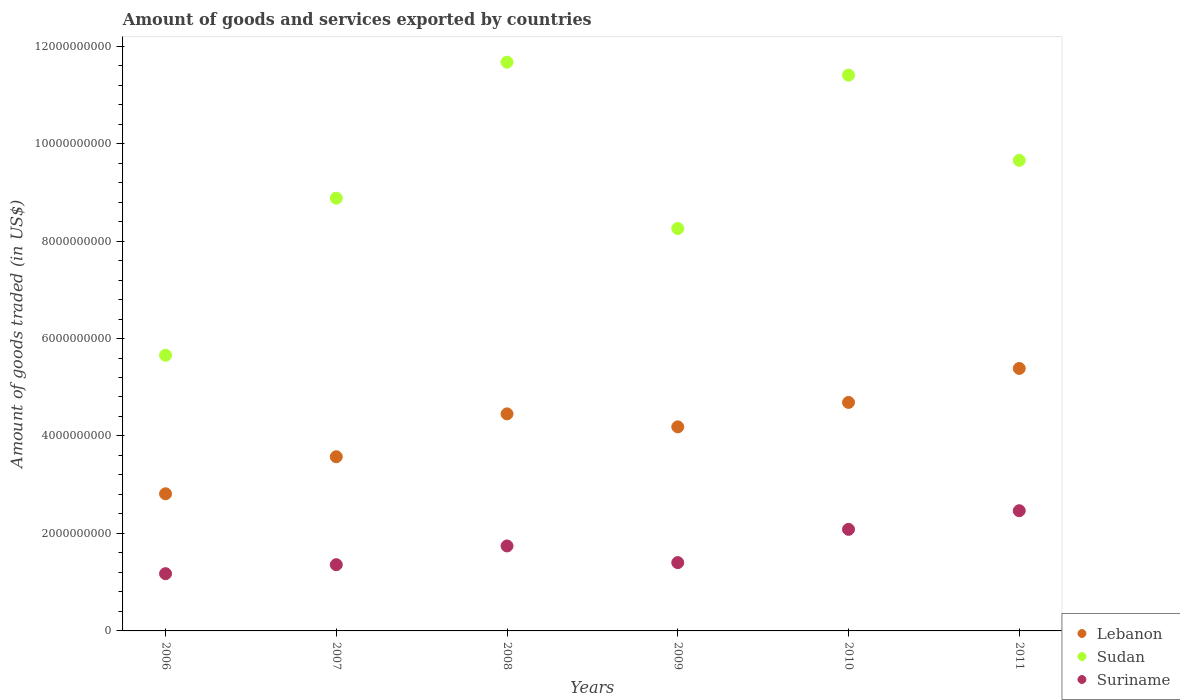Is the number of dotlines equal to the number of legend labels?
Ensure brevity in your answer.  Yes. What is the total amount of goods and services exported in Sudan in 2011?
Ensure brevity in your answer.  9.66e+09. Across all years, what is the maximum total amount of goods and services exported in Lebanon?
Offer a terse response. 5.39e+09. Across all years, what is the minimum total amount of goods and services exported in Sudan?
Your response must be concise. 5.66e+09. What is the total total amount of goods and services exported in Suriname in the graph?
Make the answer very short. 1.02e+1. What is the difference between the total amount of goods and services exported in Suriname in 2008 and that in 2011?
Keep it short and to the point. -7.23e+08. What is the difference between the total amount of goods and services exported in Suriname in 2011 and the total amount of goods and services exported in Sudan in 2010?
Ensure brevity in your answer.  -8.94e+09. What is the average total amount of goods and services exported in Suriname per year?
Provide a succinct answer. 1.70e+09. In the year 2009, what is the difference between the total amount of goods and services exported in Suriname and total amount of goods and services exported in Sudan?
Make the answer very short. -6.86e+09. What is the ratio of the total amount of goods and services exported in Suriname in 2007 to that in 2010?
Keep it short and to the point. 0.65. Is the difference between the total amount of goods and services exported in Suriname in 2007 and 2011 greater than the difference between the total amount of goods and services exported in Sudan in 2007 and 2011?
Your answer should be very brief. No. What is the difference between the highest and the second highest total amount of goods and services exported in Sudan?
Give a very brief answer. 2.66e+08. What is the difference between the highest and the lowest total amount of goods and services exported in Suriname?
Offer a very short reply. 1.29e+09. In how many years, is the total amount of goods and services exported in Suriname greater than the average total amount of goods and services exported in Suriname taken over all years?
Your response must be concise. 3. Is the total amount of goods and services exported in Lebanon strictly less than the total amount of goods and services exported in Sudan over the years?
Give a very brief answer. Yes. How are the legend labels stacked?
Offer a very short reply. Vertical. What is the title of the graph?
Keep it short and to the point. Amount of goods and services exported by countries. What is the label or title of the X-axis?
Provide a succinct answer. Years. What is the label or title of the Y-axis?
Keep it short and to the point. Amount of goods traded (in US$). What is the Amount of goods traded (in US$) in Lebanon in 2006?
Offer a terse response. 2.81e+09. What is the Amount of goods traded (in US$) in Sudan in 2006?
Make the answer very short. 5.66e+09. What is the Amount of goods traded (in US$) in Suriname in 2006?
Give a very brief answer. 1.17e+09. What is the Amount of goods traded (in US$) in Lebanon in 2007?
Keep it short and to the point. 3.57e+09. What is the Amount of goods traded (in US$) in Sudan in 2007?
Ensure brevity in your answer.  8.88e+09. What is the Amount of goods traded (in US$) of Suriname in 2007?
Make the answer very short. 1.36e+09. What is the Amount of goods traded (in US$) in Lebanon in 2008?
Keep it short and to the point. 4.45e+09. What is the Amount of goods traded (in US$) of Sudan in 2008?
Provide a succinct answer. 1.17e+1. What is the Amount of goods traded (in US$) of Suriname in 2008?
Provide a succinct answer. 1.74e+09. What is the Amount of goods traded (in US$) of Lebanon in 2009?
Your answer should be compact. 4.19e+09. What is the Amount of goods traded (in US$) in Sudan in 2009?
Your response must be concise. 8.26e+09. What is the Amount of goods traded (in US$) of Suriname in 2009?
Provide a short and direct response. 1.40e+09. What is the Amount of goods traded (in US$) of Lebanon in 2010?
Offer a terse response. 4.69e+09. What is the Amount of goods traded (in US$) in Sudan in 2010?
Your answer should be compact. 1.14e+1. What is the Amount of goods traded (in US$) of Suriname in 2010?
Make the answer very short. 2.08e+09. What is the Amount of goods traded (in US$) in Lebanon in 2011?
Keep it short and to the point. 5.39e+09. What is the Amount of goods traded (in US$) of Sudan in 2011?
Make the answer very short. 9.66e+09. What is the Amount of goods traded (in US$) of Suriname in 2011?
Offer a terse response. 2.47e+09. Across all years, what is the maximum Amount of goods traded (in US$) of Lebanon?
Make the answer very short. 5.39e+09. Across all years, what is the maximum Amount of goods traded (in US$) of Sudan?
Offer a very short reply. 1.17e+1. Across all years, what is the maximum Amount of goods traded (in US$) in Suriname?
Offer a terse response. 2.47e+09. Across all years, what is the minimum Amount of goods traded (in US$) of Lebanon?
Ensure brevity in your answer.  2.81e+09. Across all years, what is the minimum Amount of goods traded (in US$) of Sudan?
Provide a short and direct response. 5.66e+09. Across all years, what is the minimum Amount of goods traded (in US$) of Suriname?
Your answer should be very brief. 1.17e+09. What is the total Amount of goods traded (in US$) in Lebanon in the graph?
Your response must be concise. 2.51e+1. What is the total Amount of goods traded (in US$) in Sudan in the graph?
Provide a short and direct response. 5.55e+1. What is the total Amount of goods traded (in US$) in Suriname in the graph?
Your answer should be very brief. 1.02e+1. What is the difference between the Amount of goods traded (in US$) in Lebanon in 2006 and that in 2007?
Make the answer very short. -7.60e+08. What is the difference between the Amount of goods traded (in US$) in Sudan in 2006 and that in 2007?
Provide a short and direct response. -3.22e+09. What is the difference between the Amount of goods traded (in US$) of Suriname in 2006 and that in 2007?
Your answer should be very brief. -1.84e+08. What is the difference between the Amount of goods traded (in US$) of Lebanon in 2006 and that in 2008?
Provide a succinct answer. -1.64e+09. What is the difference between the Amount of goods traded (in US$) in Sudan in 2006 and that in 2008?
Offer a terse response. -6.01e+09. What is the difference between the Amount of goods traded (in US$) of Suriname in 2006 and that in 2008?
Give a very brief answer. -5.69e+08. What is the difference between the Amount of goods traded (in US$) in Lebanon in 2006 and that in 2009?
Provide a succinct answer. -1.37e+09. What is the difference between the Amount of goods traded (in US$) of Sudan in 2006 and that in 2009?
Ensure brevity in your answer.  -2.60e+09. What is the difference between the Amount of goods traded (in US$) in Suriname in 2006 and that in 2009?
Your answer should be compact. -2.27e+08. What is the difference between the Amount of goods traded (in US$) of Lebanon in 2006 and that in 2010?
Make the answer very short. -1.87e+09. What is the difference between the Amount of goods traded (in US$) of Sudan in 2006 and that in 2010?
Keep it short and to the point. -5.75e+09. What is the difference between the Amount of goods traded (in US$) of Suriname in 2006 and that in 2010?
Provide a short and direct response. -9.10e+08. What is the difference between the Amount of goods traded (in US$) in Lebanon in 2006 and that in 2011?
Ensure brevity in your answer.  -2.57e+09. What is the difference between the Amount of goods traded (in US$) of Sudan in 2006 and that in 2011?
Your response must be concise. -4.00e+09. What is the difference between the Amount of goods traded (in US$) in Suriname in 2006 and that in 2011?
Keep it short and to the point. -1.29e+09. What is the difference between the Amount of goods traded (in US$) of Lebanon in 2007 and that in 2008?
Your response must be concise. -8.79e+08. What is the difference between the Amount of goods traded (in US$) of Sudan in 2007 and that in 2008?
Ensure brevity in your answer.  -2.79e+09. What is the difference between the Amount of goods traded (in US$) in Suriname in 2007 and that in 2008?
Keep it short and to the point. -3.84e+08. What is the difference between the Amount of goods traded (in US$) of Lebanon in 2007 and that in 2009?
Ensure brevity in your answer.  -6.13e+08. What is the difference between the Amount of goods traded (in US$) of Sudan in 2007 and that in 2009?
Ensure brevity in your answer.  6.22e+08. What is the difference between the Amount of goods traded (in US$) in Suriname in 2007 and that in 2009?
Offer a very short reply. -4.28e+07. What is the difference between the Amount of goods traded (in US$) of Lebanon in 2007 and that in 2010?
Offer a terse response. -1.11e+09. What is the difference between the Amount of goods traded (in US$) in Sudan in 2007 and that in 2010?
Offer a terse response. -2.53e+09. What is the difference between the Amount of goods traded (in US$) of Suriname in 2007 and that in 2010?
Your answer should be very brief. -7.25e+08. What is the difference between the Amount of goods traded (in US$) in Lebanon in 2007 and that in 2011?
Offer a very short reply. -1.81e+09. What is the difference between the Amount of goods traded (in US$) in Sudan in 2007 and that in 2011?
Make the answer very short. -7.76e+08. What is the difference between the Amount of goods traded (in US$) in Suriname in 2007 and that in 2011?
Offer a terse response. -1.11e+09. What is the difference between the Amount of goods traded (in US$) in Lebanon in 2008 and that in 2009?
Provide a succinct answer. 2.67e+08. What is the difference between the Amount of goods traded (in US$) in Sudan in 2008 and that in 2009?
Your answer should be very brief. 3.41e+09. What is the difference between the Amount of goods traded (in US$) of Suriname in 2008 and that in 2009?
Offer a very short reply. 3.42e+08. What is the difference between the Amount of goods traded (in US$) of Lebanon in 2008 and that in 2010?
Make the answer very short. -2.35e+08. What is the difference between the Amount of goods traded (in US$) of Sudan in 2008 and that in 2010?
Make the answer very short. 2.66e+08. What is the difference between the Amount of goods traded (in US$) of Suriname in 2008 and that in 2010?
Give a very brief answer. -3.41e+08. What is the difference between the Amount of goods traded (in US$) in Lebanon in 2008 and that in 2011?
Offer a very short reply. -9.32e+08. What is the difference between the Amount of goods traded (in US$) of Sudan in 2008 and that in 2011?
Provide a succinct answer. 2.01e+09. What is the difference between the Amount of goods traded (in US$) in Suriname in 2008 and that in 2011?
Keep it short and to the point. -7.23e+08. What is the difference between the Amount of goods traded (in US$) of Lebanon in 2009 and that in 2010?
Ensure brevity in your answer.  -5.02e+08. What is the difference between the Amount of goods traded (in US$) of Sudan in 2009 and that in 2010?
Offer a very short reply. -3.15e+09. What is the difference between the Amount of goods traded (in US$) in Suriname in 2009 and that in 2010?
Offer a terse response. -6.82e+08. What is the difference between the Amount of goods traded (in US$) of Lebanon in 2009 and that in 2011?
Offer a very short reply. -1.20e+09. What is the difference between the Amount of goods traded (in US$) in Sudan in 2009 and that in 2011?
Give a very brief answer. -1.40e+09. What is the difference between the Amount of goods traded (in US$) in Suriname in 2009 and that in 2011?
Your response must be concise. -1.06e+09. What is the difference between the Amount of goods traded (in US$) in Lebanon in 2010 and that in 2011?
Offer a very short reply. -6.97e+08. What is the difference between the Amount of goods traded (in US$) in Sudan in 2010 and that in 2011?
Your answer should be compact. 1.75e+09. What is the difference between the Amount of goods traded (in US$) in Suriname in 2010 and that in 2011?
Keep it short and to the point. -3.83e+08. What is the difference between the Amount of goods traded (in US$) in Lebanon in 2006 and the Amount of goods traded (in US$) in Sudan in 2007?
Give a very brief answer. -6.07e+09. What is the difference between the Amount of goods traded (in US$) of Lebanon in 2006 and the Amount of goods traded (in US$) of Suriname in 2007?
Make the answer very short. 1.45e+09. What is the difference between the Amount of goods traded (in US$) of Sudan in 2006 and the Amount of goods traded (in US$) of Suriname in 2007?
Ensure brevity in your answer.  4.30e+09. What is the difference between the Amount of goods traded (in US$) of Lebanon in 2006 and the Amount of goods traded (in US$) of Sudan in 2008?
Your answer should be compact. -8.86e+09. What is the difference between the Amount of goods traded (in US$) in Lebanon in 2006 and the Amount of goods traded (in US$) in Suriname in 2008?
Keep it short and to the point. 1.07e+09. What is the difference between the Amount of goods traded (in US$) of Sudan in 2006 and the Amount of goods traded (in US$) of Suriname in 2008?
Your answer should be very brief. 3.91e+09. What is the difference between the Amount of goods traded (in US$) in Lebanon in 2006 and the Amount of goods traded (in US$) in Sudan in 2009?
Keep it short and to the point. -5.44e+09. What is the difference between the Amount of goods traded (in US$) in Lebanon in 2006 and the Amount of goods traded (in US$) in Suriname in 2009?
Give a very brief answer. 1.41e+09. What is the difference between the Amount of goods traded (in US$) in Sudan in 2006 and the Amount of goods traded (in US$) in Suriname in 2009?
Ensure brevity in your answer.  4.25e+09. What is the difference between the Amount of goods traded (in US$) in Lebanon in 2006 and the Amount of goods traded (in US$) in Sudan in 2010?
Your answer should be very brief. -8.59e+09. What is the difference between the Amount of goods traded (in US$) of Lebanon in 2006 and the Amount of goods traded (in US$) of Suriname in 2010?
Keep it short and to the point. 7.30e+08. What is the difference between the Amount of goods traded (in US$) in Sudan in 2006 and the Amount of goods traded (in US$) in Suriname in 2010?
Make the answer very short. 3.57e+09. What is the difference between the Amount of goods traded (in US$) of Lebanon in 2006 and the Amount of goods traded (in US$) of Sudan in 2011?
Your answer should be very brief. -6.84e+09. What is the difference between the Amount of goods traded (in US$) in Lebanon in 2006 and the Amount of goods traded (in US$) in Suriname in 2011?
Provide a short and direct response. 3.47e+08. What is the difference between the Amount of goods traded (in US$) in Sudan in 2006 and the Amount of goods traded (in US$) in Suriname in 2011?
Your answer should be very brief. 3.19e+09. What is the difference between the Amount of goods traded (in US$) of Lebanon in 2007 and the Amount of goods traded (in US$) of Sudan in 2008?
Make the answer very short. -8.10e+09. What is the difference between the Amount of goods traded (in US$) in Lebanon in 2007 and the Amount of goods traded (in US$) in Suriname in 2008?
Your answer should be compact. 1.83e+09. What is the difference between the Amount of goods traded (in US$) of Sudan in 2007 and the Amount of goods traded (in US$) of Suriname in 2008?
Your answer should be compact. 7.14e+09. What is the difference between the Amount of goods traded (in US$) in Lebanon in 2007 and the Amount of goods traded (in US$) in Sudan in 2009?
Your answer should be compact. -4.68e+09. What is the difference between the Amount of goods traded (in US$) of Lebanon in 2007 and the Amount of goods traded (in US$) of Suriname in 2009?
Offer a terse response. 2.17e+09. What is the difference between the Amount of goods traded (in US$) of Sudan in 2007 and the Amount of goods traded (in US$) of Suriname in 2009?
Provide a short and direct response. 7.48e+09. What is the difference between the Amount of goods traded (in US$) in Lebanon in 2007 and the Amount of goods traded (in US$) in Sudan in 2010?
Offer a very short reply. -7.83e+09. What is the difference between the Amount of goods traded (in US$) in Lebanon in 2007 and the Amount of goods traded (in US$) in Suriname in 2010?
Your response must be concise. 1.49e+09. What is the difference between the Amount of goods traded (in US$) in Sudan in 2007 and the Amount of goods traded (in US$) in Suriname in 2010?
Give a very brief answer. 6.80e+09. What is the difference between the Amount of goods traded (in US$) of Lebanon in 2007 and the Amount of goods traded (in US$) of Sudan in 2011?
Give a very brief answer. -6.08e+09. What is the difference between the Amount of goods traded (in US$) of Lebanon in 2007 and the Amount of goods traded (in US$) of Suriname in 2011?
Give a very brief answer. 1.11e+09. What is the difference between the Amount of goods traded (in US$) of Sudan in 2007 and the Amount of goods traded (in US$) of Suriname in 2011?
Your answer should be very brief. 6.41e+09. What is the difference between the Amount of goods traded (in US$) of Lebanon in 2008 and the Amount of goods traded (in US$) of Sudan in 2009?
Keep it short and to the point. -3.80e+09. What is the difference between the Amount of goods traded (in US$) of Lebanon in 2008 and the Amount of goods traded (in US$) of Suriname in 2009?
Ensure brevity in your answer.  3.05e+09. What is the difference between the Amount of goods traded (in US$) in Sudan in 2008 and the Amount of goods traded (in US$) in Suriname in 2009?
Provide a succinct answer. 1.03e+1. What is the difference between the Amount of goods traded (in US$) in Lebanon in 2008 and the Amount of goods traded (in US$) in Sudan in 2010?
Offer a terse response. -6.95e+09. What is the difference between the Amount of goods traded (in US$) in Lebanon in 2008 and the Amount of goods traded (in US$) in Suriname in 2010?
Offer a terse response. 2.37e+09. What is the difference between the Amount of goods traded (in US$) of Sudan in 2008 and the Amount of goods traded (in US$) of Suriname in 2010?
Your answer should be very brief. 9.59e+09. What is the difference between the Amount of goods traded (in US$) of Lebanon in 2008 and the Amount of goods traded (in US$) of Sudan in 2011?
Provide a succinct answer. -5.20e+09. What is the difference between the Amount of goods traded (in US$) of Lebanon in 2008 and the Amount of goods traded (in US$) of Suriname in 2011?
Your answer should be very brief. 1.99e+09. What is the difference between the Amount of goods traded (in US$) in Sudan in 2008 and the Amount of goods traded (in US$) in Suriname in 2011?
Offer a terse response. 9.20e+09. What is the difference between the Amount of goods traded (in US$) in Lebanon in 2009 and the Amount of goods traded (in US$) in Sudan in 2010?
Give a very brief answer. -7.22e+09. What is the difference between the Amount of goods traded (in US$) in Lebanon in 2009 and the Amount of goods traded (in US$) in Suriname in 2010?
Your response must be concise. 2.10e+09. What is the difference between the Amount of goods traded (in US$) in Sudan in 2009 and the Amount of goods traded (in US$) in Suriname in 2010?
Your response must be concise. 6.17e+09. What is the difference between the Amount of goods traded (in US$) in Lebanon in 2009 and the Amount of goods traded (in US$) in Sudan in 2011?
Offer a terse response. -5.47e+09. What is the difference between the Amount of goods traded (in US$) in Lebanon in 2009 and the Amount of goods traded (in US$) in Suriname in 2011?
Your response must be concise. 1.72e+09. What is the difference between the Amount of goods traded (in US$) of Sudan in 2009 and the Amount of goods traded (in US$) of Suriname in 2011?
Give a very brief answer. 5.79e+09. What is the difference between the Amount of goods traded (in US$) of Lebanon in 2010 and the Amount of goods traded (in US$) of Sudan in 2011?
Your response must be concise. -4.97e+09. What is the difference between the Amount of goods traded (in US$) of Lebanon in 2010 and the Amount of goods traded (in US$) of Suriname in 2011?
Offer a very short reply. 2.22e+09. What is the difference between the Amount of goods traded (in US$) of Sudan in 2010 and the Amount of goods traded (in US$) of Suriname in 2011?
Offer a terse response. 8.94e+09. What is the average Amount of goods traded (in US$) in Lebanon per year?
Make the answer very short. 4.18e+09. What is the average Amount of goods traded (in US$) in Sudan per year?
Your answer should be compact. 9.25e+09. What is the average Amount of goods traded (in US$) in Suriname per year?
Offer a terse response. 1.70e+09. In the year 2006, what is the difference between the Amount of goods traded (in US$) of Lebanon and Amount of goods traded (in US$) of Sudan?
Provide a short and direct response. -2.84e+09. In the year 2006, what is the difference between the Amount of goods traded (in US$) in Lebanon and Amount of goods traded (in US$) in Suriname?
Your response must be concise. 1.64e+09. In the year 2006, what is the difference between the Amount of goods traded (in US$) in Sudan and Amount of goods traded (in US$) in Suriname?
Provide a short and direct response. 4.48e+09. In the year 2007, what is the difference between the Amount of goods traded (in US$) of Lebanon and Amount of goods traded (in US$) of Sudan?
Give a very brief answer. -5.30e+09. In the year 2007, what is the difference between the Amount of goods traded (in US$) of Lebanon and Amount of goods traded (in US$) of Suriname?
Make the answer very short. 2.22e+09. In the year 2007, what is the difference between the Amount of goods traded (in US$) in Sudan and Amount of goods traded (in US$) in Suriname?
Your answer should be compact. 7.52e+09. In the year 2008, what is the difference between the Amount of goods traded (in US$) of Lebanon and Amount of goods traded (in US$) of Sudan?
Your answer should be compact. -7.22e+09. In the year 2008, what is the difference between the Amount of goods traded (in US$) of Lebanon and Amount of goods traded (in US$) of Suriname?
Your response must be concise. 2.71e+09. In the year 2008, what is the difference between the Amount of goods traded (in US$) in Sudan and Amount of goods traded (in US$) in Suriname?
Ensure brevity in your answer.  9.93e+09. In the year 2009, what is the difference between the Amount of goods traded (in US$) in Lebanon and Amount of goods traded (in US$) in Sudan?
Provide a succinct answer. -4.07e+09. In the year 2009, what is the difference between the Amount of goods traded (in US$) in Lebanon and Amount of goods traded (in US$) in Suriname?
Provide a succinct answer. 2.79e+09. In the year 2009, what is the difference between the Amount of goods traded (in US$) in Sudan and Amount of goods traded (in US$) in Suriname?
Your answer should be very brief. 6.86e+09. In the year 2010, what is the difference between the Amount of goods traded (in US$) of Lebanon and Amount of goods traded (in US$) of Sudan?
Provide a succinct answer. -6.72e+09. In the year 2010, what is the difference between the Amount of goods traded (in US$) in Lebanon and Amount of goods traded (in US$) in Suriname?
Your response must be concise. 2.60e+09. In the year 2010, what is the difference between the Amount of goods traded (in US$) of Sudan and Amount of goods traded (in US$) of Suriname?
Give a very brief answer. 9.32e+09. In the year 2011, what is the difference between the Amount of goods traded (in US$) in Lebanon and Amount of goods traded (in US$) in Sudan?
Your answer should be very brief. -4.27e+09. In the year 2011, what is the difference between the Amount of goods traded (in US$) of Lebanon and Amount of goods traded (in US$) of Suriname?
Give a very brief answer. 2.92e+09. In the year 2011, what is the difference between the Amount of goods traded (in US$) of Sudan and Amount of goods traded (in US$) of Suriname?
Provide a succinct answer. 7.19e+09. What is the ratio of the Amount of goods traded (in US$) of Lebanon in 2006 to that in 2007?
Offer a very short reply. 0.79. What is the ratio of the Amount of goods traded (in US$) in Sudan in 2006 to that in 2007?
Give a very brief answer. 0.64. What is the ratio of the Amount of goods traded (in US$) of Suriname in 2006 to that in 2007?
Give a very brief answer. 0.86. What is the ratio of the Amount of goods traded (in US$) in Lebanon in 2006 to that in 2008?
Provide a short and direct response. 0.63. What is the ratio of the Amount of goods traded (in US$) in Sudan in 2006 to that in 2008?
Your answer should be very brief. 0.48. What is the ratio of the Amount of goods traded (in US$) in Suriname in 2006 to that in 2008?
Provide a succinct answer. 0.67. What is the ratio of the Amount of goods traded (in US$) of Lebanon in 2006 to that in 2009?
Your answer should be compact. 0.67. What is the ratio of the Amount of goods traded (in US$) in Sudan in 2006 to that in 2009?
Keep it short and to the point. 0.69. What is the ratio of the Amount of goods traded (in US$) of Suriname in 2006 to that in 2009?
Ensure brevity in your answer.  0.84. What is the ratio of the Amount of goods traded (in US$) of Lebanon in 2006 to that in 2010?
Offer a terse response. 0.6. What is the ratio of the Amount of goods traded (in US$) in Sudan in 2006 to that in 2010?
Your answer should be compact. 0.5. What is the ratio of the Amount of goods traded (in US$) in Suriname in 2006 to that in 2010?
Offer a very short reply. 0.56. What is the ratio of the Amount of goods traded (in US$) of Lebanon in 2006 to that in 2011?
Make the answer very short. 0.52. What is the ratio of the Amount of goods traded (in US$) in Sudan in 2006 to that in 2011?
Make the answer very short. 0.59. What is the ratio of the Amount of goods traded (in US$) of Suriname in 2006 to that in 2011?
Give a very brief answer. 0.48. What is the ratio of the Amount of goods traded (in US$) in Lebanon in 2007 to that in 2008?
Keep it short and to the point. 0.8. What is the ratio of the Amount of goods traded (in US$) of Sudan in 2007 to that in 2008?
Your response must be concise. 0.76. What is the ratio of the Amount of goods traded (in US$) in Suriname in 2007 to that in 2008?
Provide a short and direct response. 0.78. What is the ratio of the Amount of goods traded (in US$) in Lebanon in 2007 to that in 2009?
Make the answer very short. 0.85. What is the ratio of the Amount of goods traded (in US$) of Sudan in 2007 to that in 2009?
Your answer should be very brief. 1.08. What is the ratio of the Amount of goods traded (in US$) of Suriname in 2007 to that in 2009?
Provide a short and direct response. 0.97. What is the ratio of the Amount of goods traded (in US$) in Lebanon in 2007 to that in 2010?
Make the answer very short. 0.76. What is the ratio of the Amount of goods traded (in US$) of Sudan in 2007 to that in 2010?
Give a very brief answer. 0.78. What is the ratio of the Amount of goods traded (in US$) of Suriname in 2007 to that in 2010?
Your answer should be very brief. 0.65. What is the ratio of the Amount of goods traded (in US$) of Lebanon in 2007 to that in 2011?
Offer a very short reply. 0.66. What is the ratio of the Amount of goods traded (in US$) in Sudan in 2007 to that in 2011?
Your answer should be compact. 0.92. What is the ratio of the Amount of goods traded (in US$) of Suriname in 2007 to that in 2011?
Your response must be concise. 0.55. What is the ratio of the Amount of goods traded (in US$) of Lebanon in 2008 to that in 2009?
Your response must be concise. 1.06. What is the ratio of the Amount of goods traded (in US$) of Sudan in 2008 to that in 2009?
Give a very brief answer. 1.41. What is the ratio of the Amount of goods traded (in US$) of Suriname in 2008 to that in 2009?
Provide a succinct answer. 1.24. What is the ratio of the Amount of goods traded (in US$) of Lebanon in 2008 to that in 2010?
Ensure brevity in your answer.  0.95. What is the ratio of the Amount of goods traded (in US$) of Sudan in 2008 to that in 2010?
Your response must be concise. 1.02. What is the ratio of the Amount of goods traded (in US$) of Suriname in 2008 to that in 2010?
Offer a terse response. 0.84. What is the ratio of the Amount of goods traded (in US$) of Lebanon in 2008 to that in 2011?
Your answer should be very brief. 0.83. What is the ratio of the Amount of goods traded (in US$) of Sudan in 2008 to that in 2011?
Provide a short and direct response. 1.21. What is the ratio of the Amount of goods traded (in US$) in Suriname in 2008 to that in 2011?
Offer a terse response. 0.71. What is the ratio of the Amount of goods traded (in US$) of Lebanon in 2009 to that in 2010?
Offer a terse response. 0.89. What is the ratio of the Amount of goods traded (in US$) of Sudan in 2009 to that in 2010?
Your answer should be very brief. 0.72. What is the ratio of the Amount of goods traded (in US$) of Suriname in 2009 to that in 2010?
Keep it short and to the point. 0.67. What is the ratio of the Amount of goods traded (in US$) of Lebanon in 2009 to that in 2011?
Provide a succinct answer. 0.78. What is the ratio of the Amount of goods traded (in US$) of Sudan in 2009 to that in 2011?
Ensure brevity in your answer.  0.86. What is the ratio of the Amount of goods traded (in US$) of Suriname in 2009 to that in 2011?
Keep it short and to the point. 0.57. What is the ratio of the Amount of goods traded (in US$) in Lebanon in 2010 to that in 2011?
Your answer should be compact. 0.87. What is the ratio of the Amount of goods traded (in US$) of Sudan in 2010 to that in 2011?
Your response must be concise. 1.18. What is the ratio of the Amount of goods traded (in US$) of Suriname in 2010 to that in 2011?
Keep it short and to the point. 0.84. What is the difference between the highest and the second highest Amount of goods traded (in US$) of Lebanon?
Provide a short and direct response. 6.97e+08. What is the difference between the highest and the second highest Amount of goods traded (in US$) in Sudan?
Provide a succinct answer. 2.66e+08. What is the difference between the highest and the second highest Amount of goods traded (in US$) of Suriname?
Your answer should be compact. 3.83e+08. What is the difference between the highest and the lowest Amount of goods traded (in US$) in Lebanon?
Provide a succinct answer. 2.57e+09. What is the difference between the highest and the lowest Amount of goods traded (in US$) of Sudan?
Provide a succinct answer. 6.01e+09. What is the difference between the highest and the lowest Amount of goods traded (in US$) in Suriname?
Your response must be concise. 1.29e+09. 